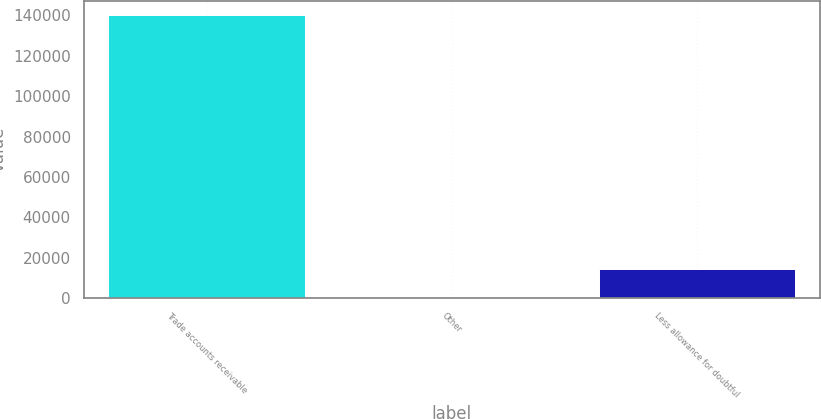Convert chart. <chart><loc_0><loc_0><loc_500><loc_500><bar_chart><fcel>Trade accounts receivable<fcel>Other<fcel>Less allowance for doubtful<nl><fcel>140340<fcel>575<fcel>14551.5<nl></chart> 